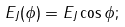<formula> <loc_0><loc_0><loc_500><loc_500>E _ { J } ( \phi ) = E _ { J } \cos \phi ;</formula> 